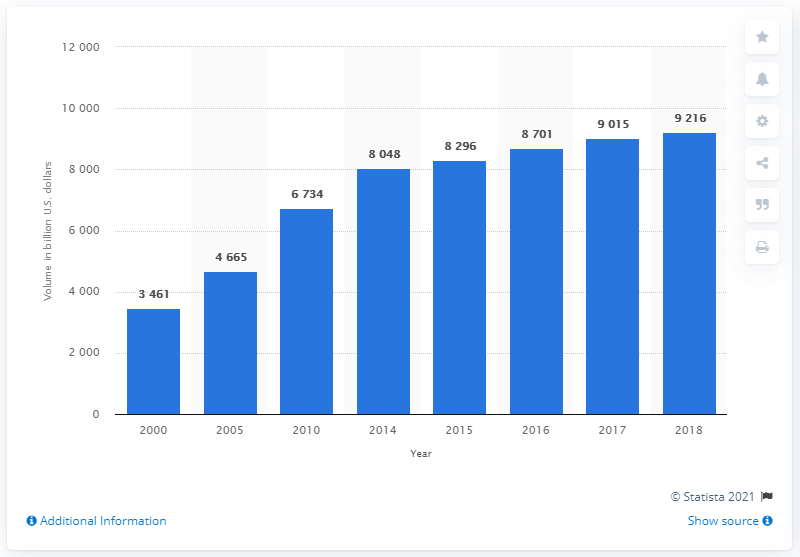List a handful of essential elements in this visual. In 2018, the total amount of corporate debt securities outstanding in the United States was approximately 92,160. 